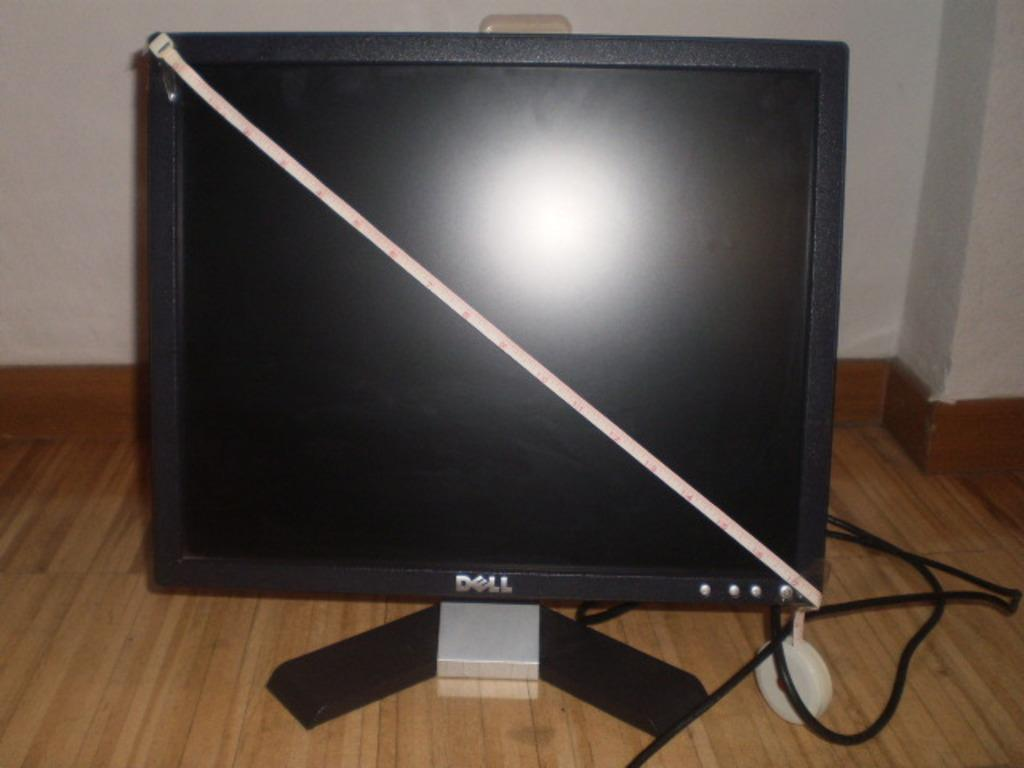<image>
Provide a brief description of the given image. the word Dell is on the screen of a computer 